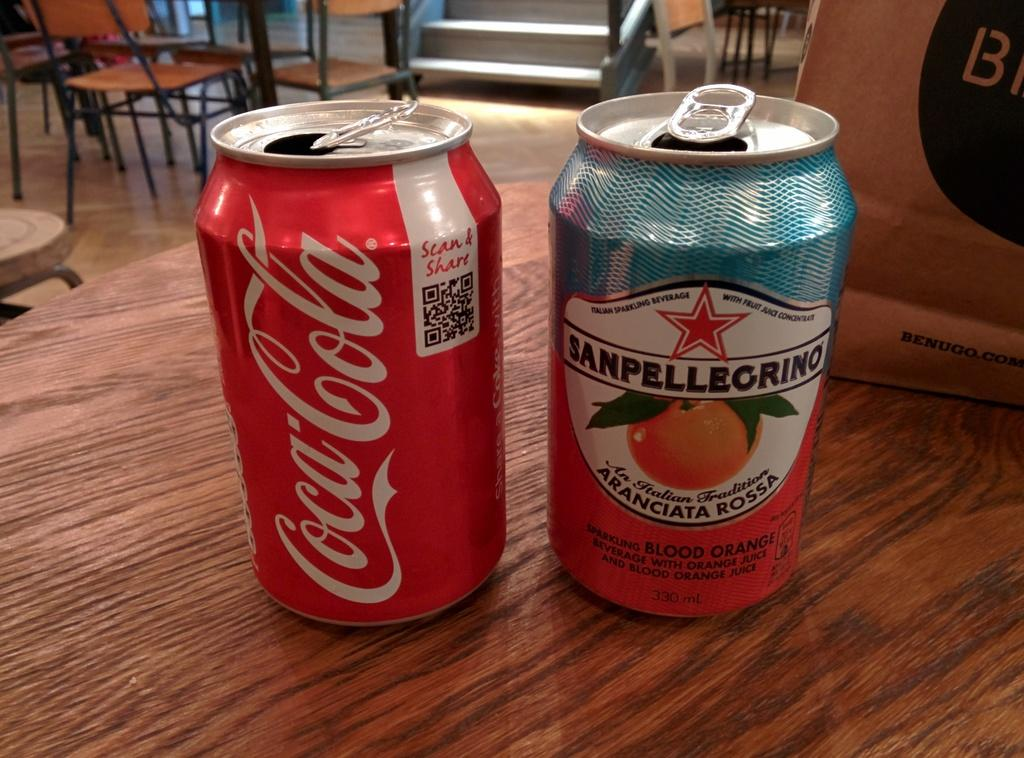<image>
Offer a succinct explanation of the picture presented. Blood orange Sanpellegrino and a can of Coca Cola are open on the table. 